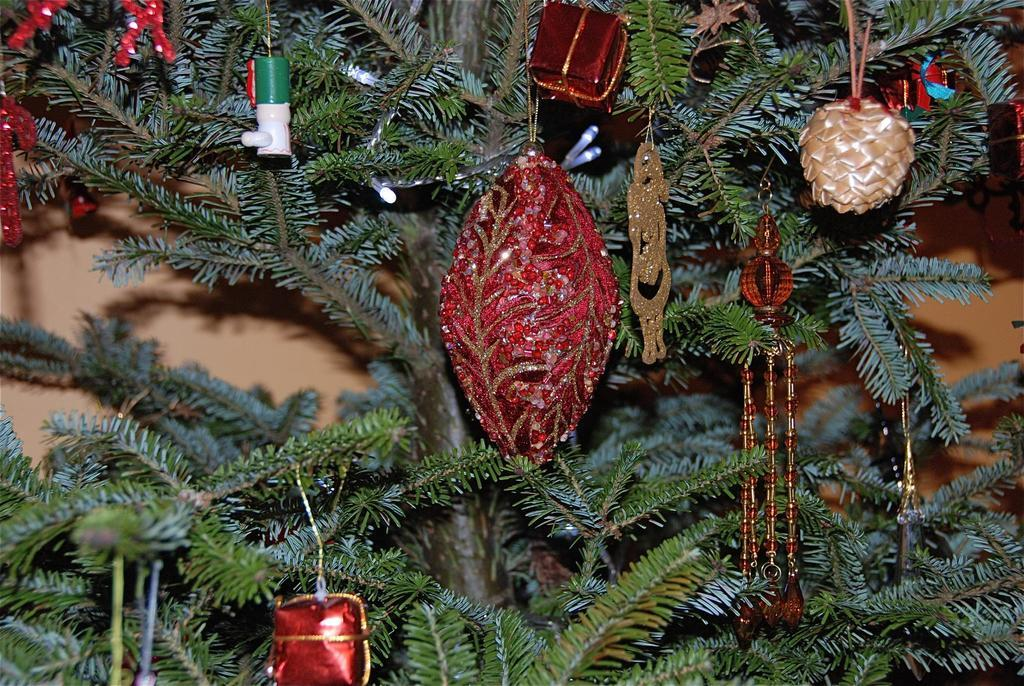What is present in the image? There is a tree in the image. What is unique about the tree in the image? The tree has decorations on it. What type of robin can be seen perched on the tree in the image? There is no robin present in the image; it only features a tree with decorations. 